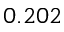Convert formula to latex. <formula><loc_0><loc_0><loc_500><loc_500>0 . 2 0 2</formula> 